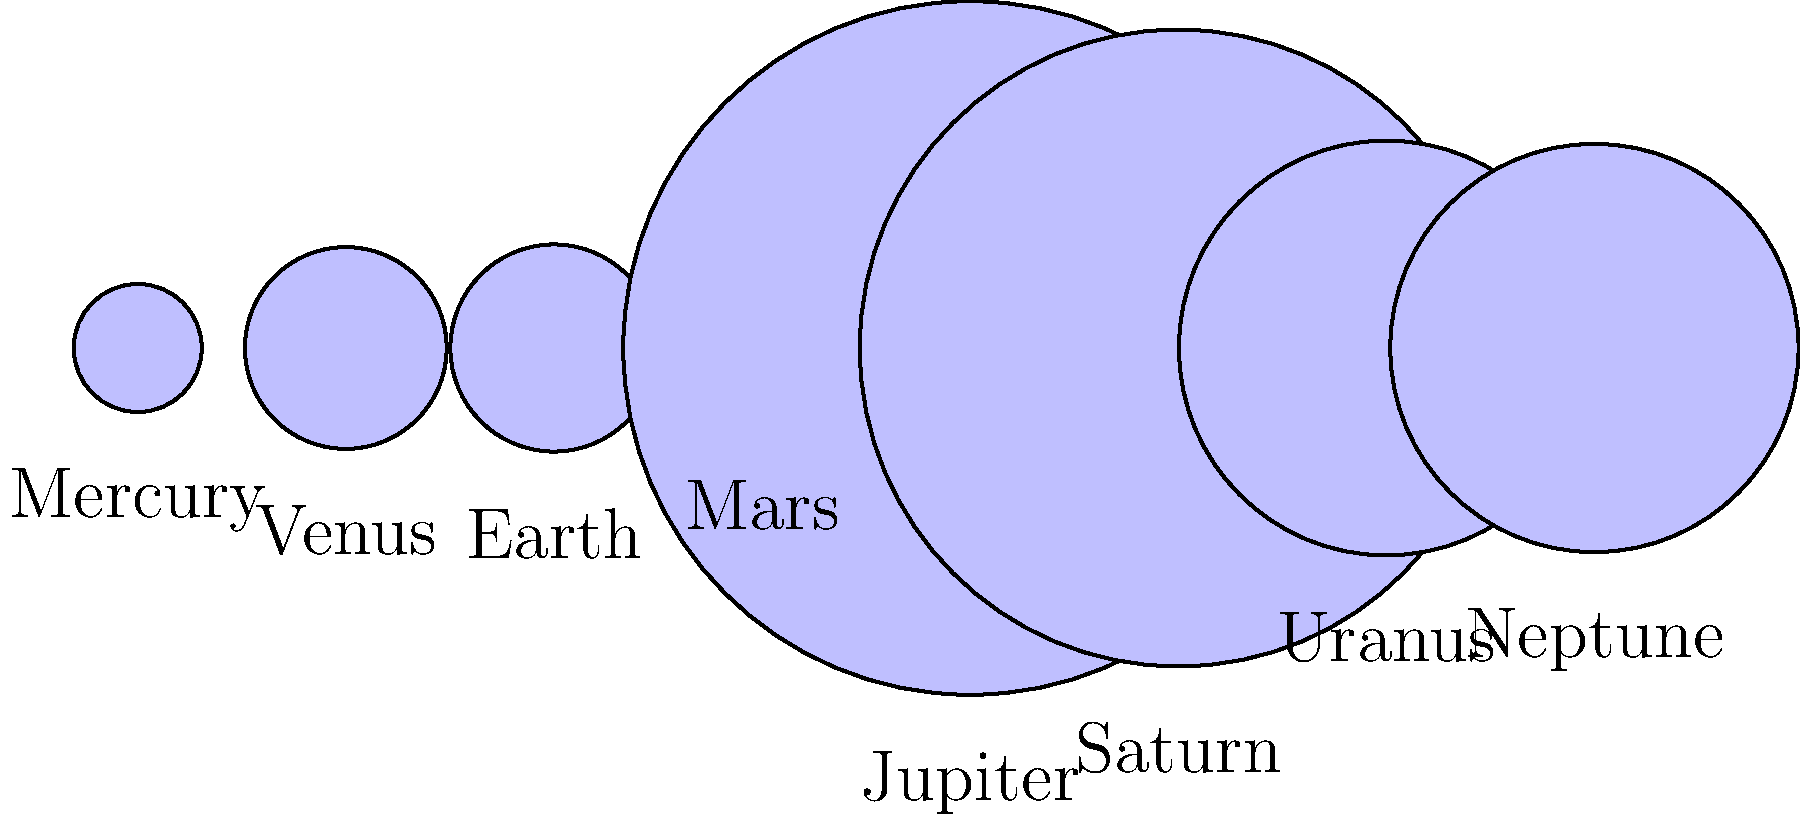In the context of future manufacturing technologies, understanding the scale of celestial bodies is crucial for space exploration and resource utilization. Based on the graphic representation of our solar system's planets, which planet has a diameter closest to twice that of Earth, and how might this impact future space manufacturing initiatives? To answer this question, we need to follow these steps:

1. Identify Earth's diameter from the data:
   Earth's diameter = 12,756 km

2. Calculate twice Earth's diameter:
   $2 \times 12,756 = 25,512$ km

3. Compare this value to the diameters of other planets:
   Mercury: 4,879 km
   Venus: 12,104 km
   Mars: 6,792 km
   Jupiter: 142,984 km
   Saturn: 120,536 km
   Uranus: 51,118 km
   Neptune: 49,528 km

4. Find the planet with the closest diameter to 25,512 km:
   Uranus (51,118 km) and Neptune (49,528 km) are the closest.

5. Determine which is closer:
   Uranus: $|51,118 - 25,512| = 25,606$ km difference
   Neptune: $|49,528 - 25,512| = 24,016$ km difference

Neptune has the closer diameter to twice that of Earth.

Impact on future space manufacturing initiatives:
Understanding the relative sizes of planets is crucial for:
a) Designing appropriate spacecraft and equipment for different gravitational environments.
b) Estimating resource availability and extraction potential on different planets.
c) Planning for energy requirements in various planetary atmospheres.
d) Developing manufacturing processes that can adapt to different planetary conditions.

Neptune's similarity in size to a hypothetical "double Earth" could provide insights into scaling up Earth-based manufacturing technologies for larger planetary environments, potentially influencing the development of more efficient and adaptable space manufacturing systems.
Answer: Neptune; influences scaling of Earth-based manufacturing for larger planetary environments. 